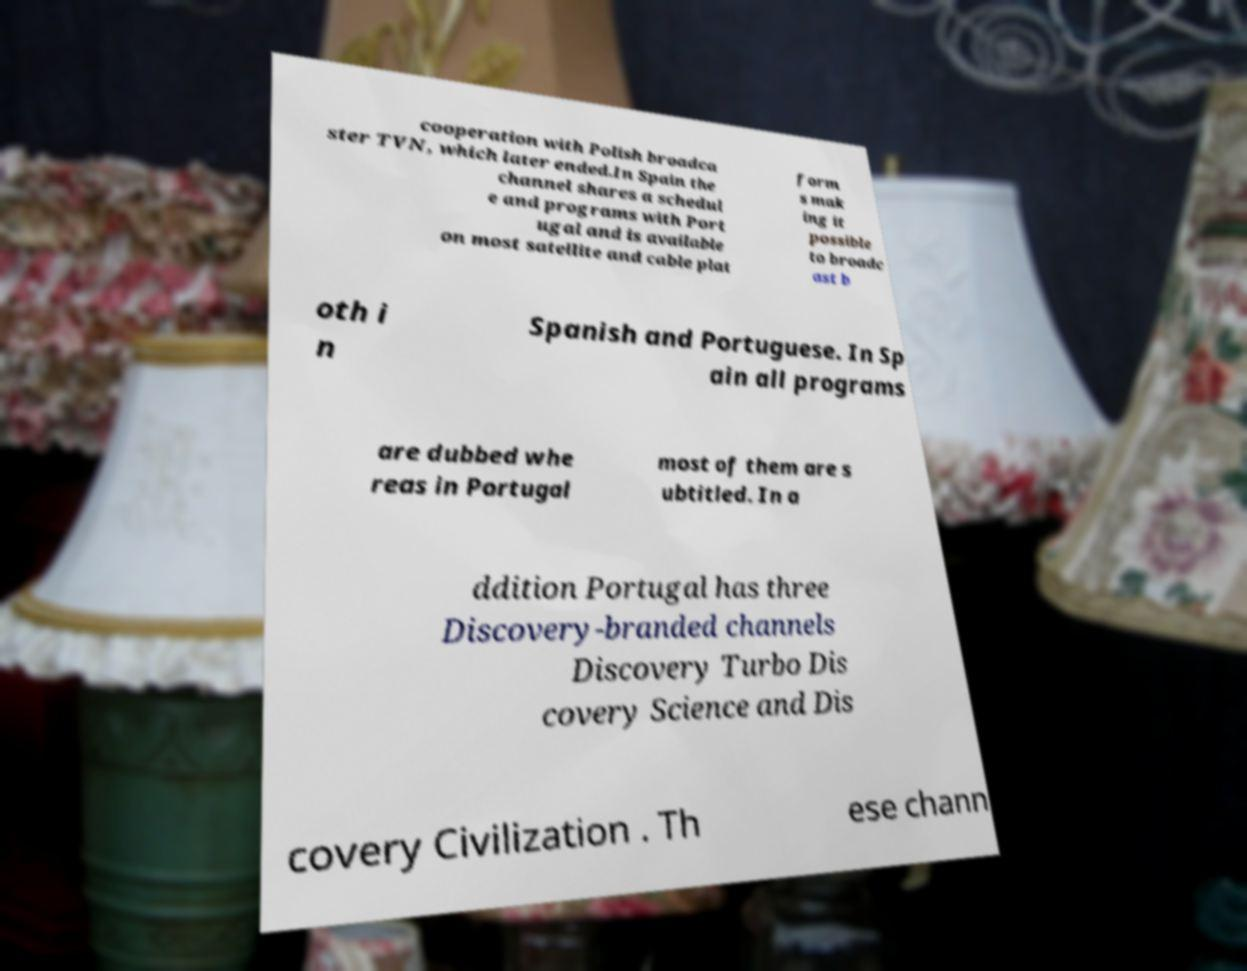Please identify and transcribe the text found in this image. cooperation with Polish broadca ster TVN, which later ended.In Spain the channel shares a schedul e and programs with Port ugal and is available on most satellite and cable plat form s mak ing it possible to broadc ast b oth i n Spanish and Portuguese. In Sp ain all programs are dubbed whe reas in Portugal most of them are s ubtitled. In a ddition Portugal has three Discovery-branded channels Discovery Turbo Dis covery Science and Dis covery Civilization . Th ese chann 